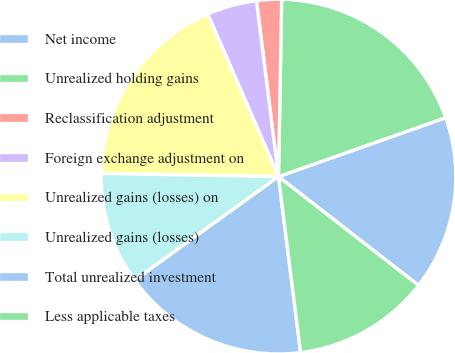<chart> <loc_0><loc_0><loc_500><loc_500><pie_chart><fcel>Net income<fcel>Unrealized holding gains<fcel>Reclassification adjustment<fcel>Foreign exchange adjustment on<fcel>Unrealized gains (losses) on<fcel>Unrealized gains (losses)<fcel>Total unrealized investment<fcel>Less applicable taxes<nl><fcel>15.91%<fcel>19.32%<fcel>2.27%<fcel>4.55%<fcel>18.18%<fcel>10.23%<fcel>17.05%<fcel>12.5%<nl></chart> 